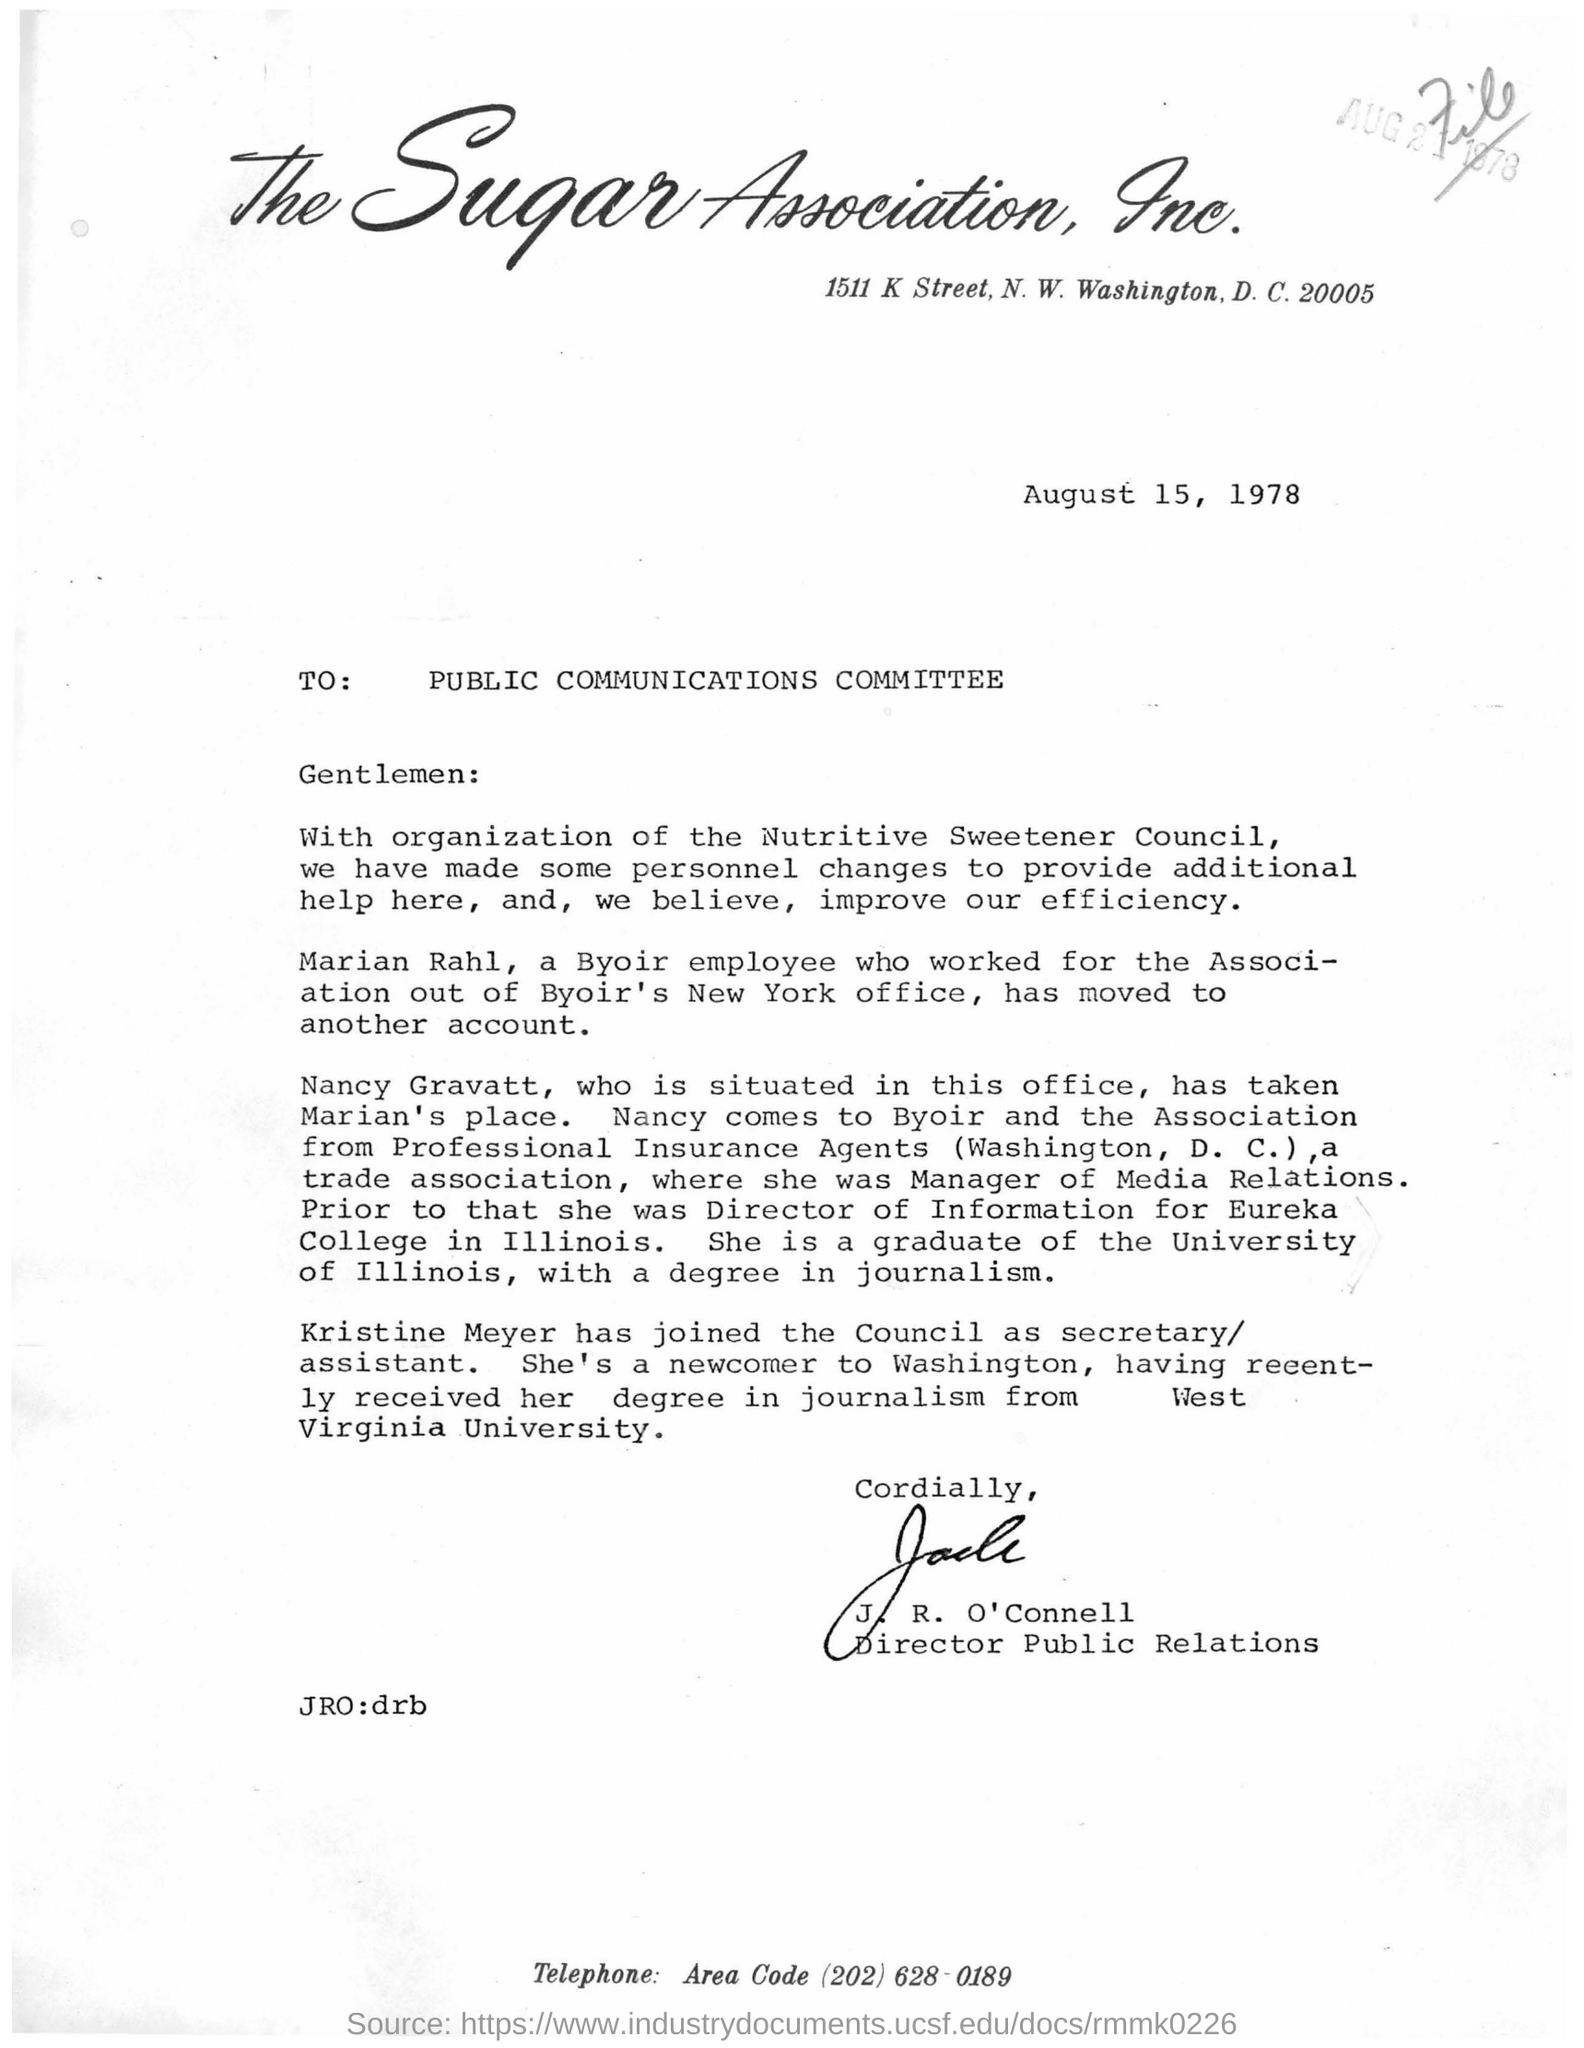Specify some key components in this picture. The letter contained a signature at the bottom that read "J. R. O'Connell. The person to whom the letter was written is the public communications committee. The date mentioned in the given page is August 15, 1978. J.R. O'Connell holds the designation of Director of Public Relations. 